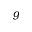<formula> <loc_0><loc_0><loc_500><loc_500>g</formula> 